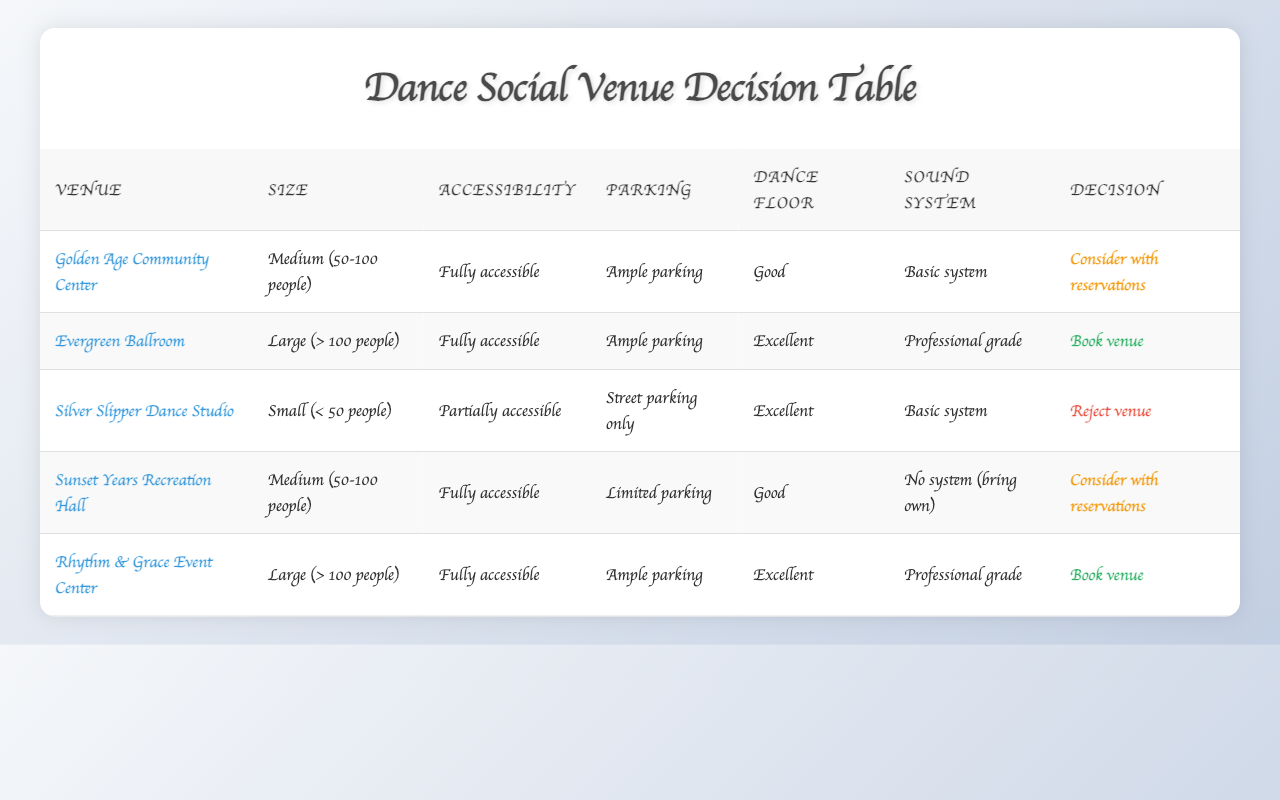What is the venue with the best dance floor quality? Looking at the 'Dance Floor Quality' column, 'Excellent' is the highest quality. The venues that have this rating are Evergreen Ballroom, Rhythm & Grace Event Center, and Silver Slipper Dance Studio. The results should be listed with their respective conditions.
Answer: Evergreen Ballroom, Rhythm & Grace Event Center Which venue has limited parking and is fully accessible? In the table, I need to check the 'Parking Availability' column for "Limited parking" and the 'Accessibility' column for "Fully accessible". The Sunset Years Recreation Hall meets both these criteria.
Answer: Sunset Years Recreation Hall How many venues can be booked? The 'Decision' column indicates that two venues can be booked: Evergreen Ballroom and Rhythm & Grace Event Center.
Answer: 2 Is the Golden Age Community Center large enough for more than 100 guests? The size of the Golden Age Community Center is listed as "Medium (50-100 people)," which means it cannot accommodate more than 100 guests. Therefore, the answer is no.
Answer: No What are the conditions of the Silver Slipper Dance Studio, and what decision was made about it? Referring to the Silver Slipper Dance Studio, we see its conditions are: size is small (< 50 people), accessibility is partially accessible, parking is street parking only, dance floor quality is excellent, and sound system is basic. According to the decision, it was rejected.
Answer: Rejected: Small, Partially accessible, Street parking only, Excellent, Basic system If we combine the parking availability of Midnight Years Recreation and Silver Slipper Dance Studio, what would that summarize into? Sunset Years Recreation Hall has limited parking while Silver Slipper Dance Studio has street parking only. Therefore, combined parking availability indicates that neither venue has ample parking options, which could be a drawback for event attendees.
Answer: Limited parking options Which venue should we consider with reservations, based on the decision table? Based on the decision column, the venues that should be considered with reservations are the Golden Age Community Center and Sunset Years Recreation Hall.
Answer: Golden Age Community Center, Sunset Years Recreation Hall What percentage of venues have a professional-grade sound system? In total, we have 5 venues listed. Among them, Evergreen Ballroom and Rhythm & Grace Event Center have a professional-grade sound system, which accounts for 2 out of 5 venues. The percentage is calculated as (2/5) * 100 = 40%.
Answer: 40% 